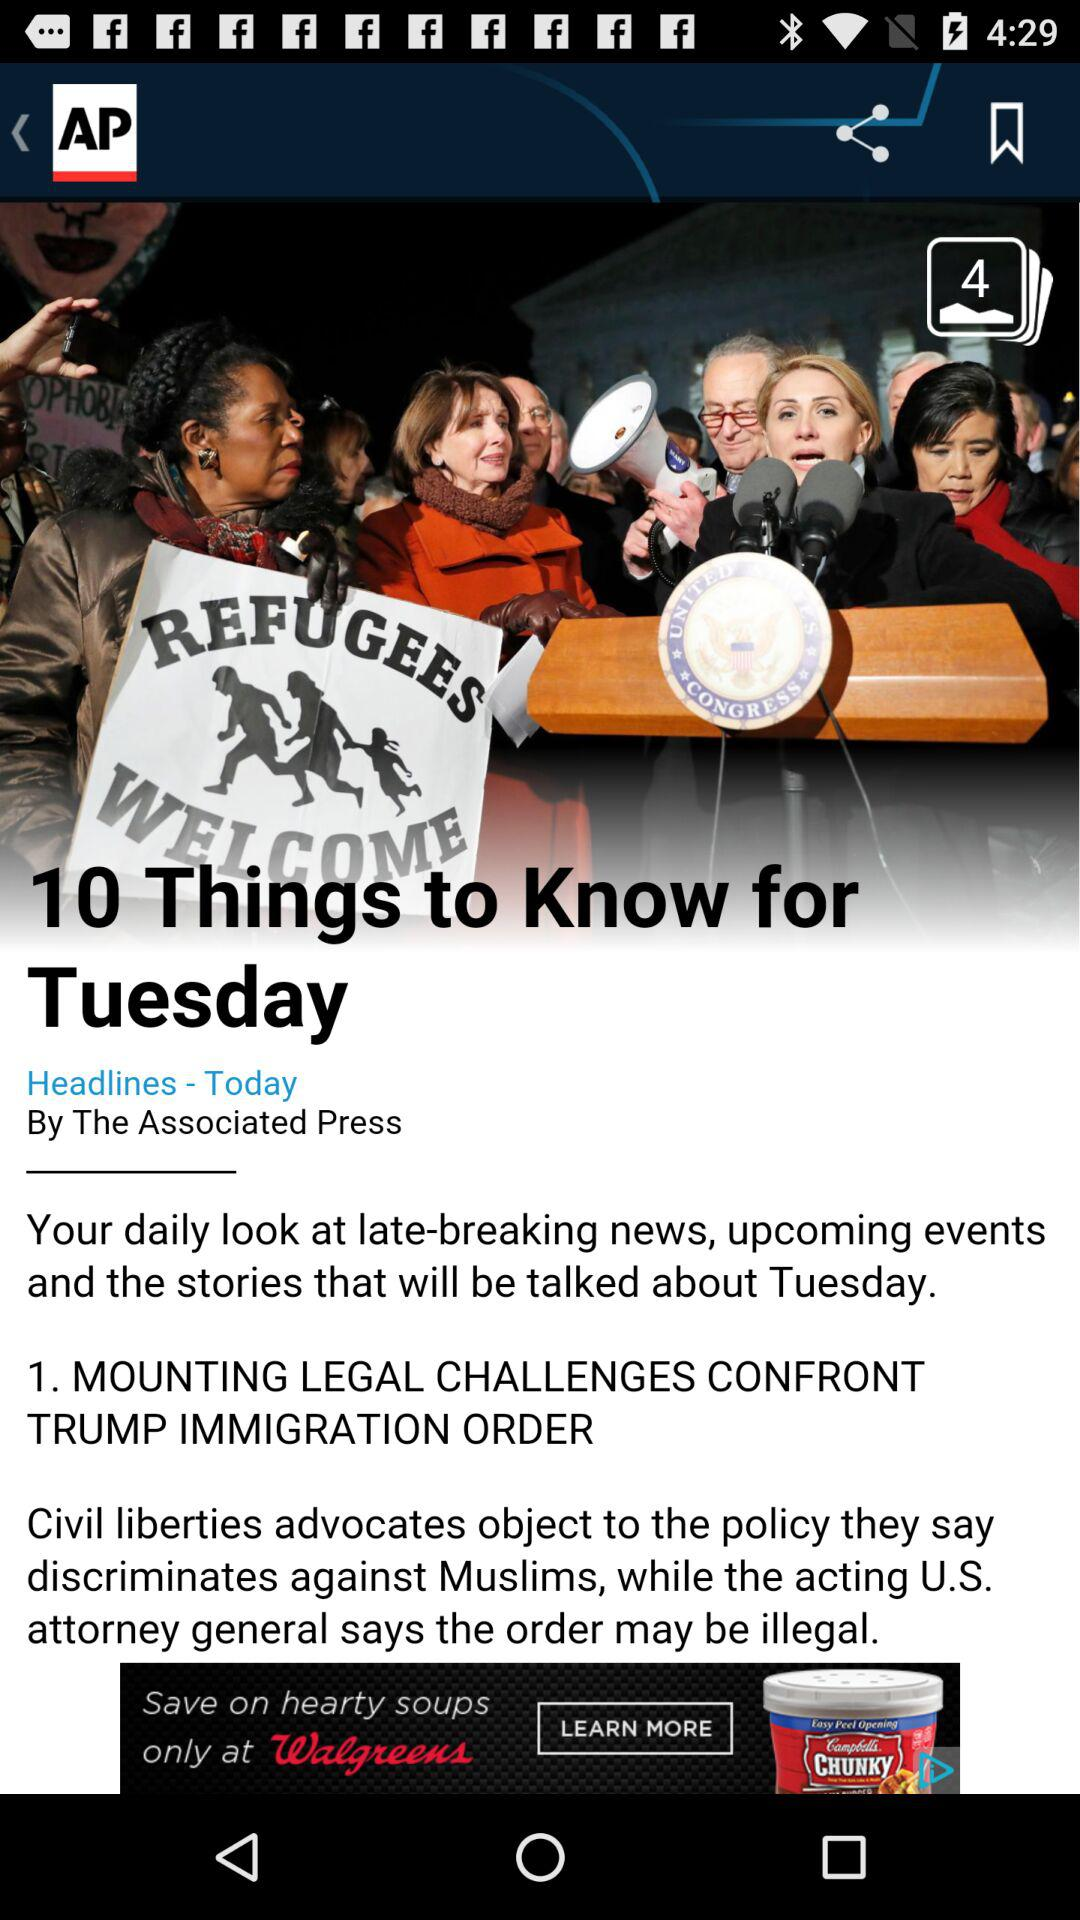What is the headline? The headline is "MOUNTING LEGAL CHALLENGES CONFRONT TRUMP IMMIGRATION ORDER ". 